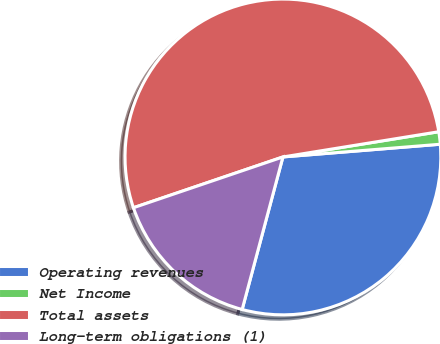<chart> <loc_0><loc_0><loc_500><loc_500><pie_chart><fcel>Operating revenues<fcel>Net Income<fcel>Total assets<fcel>Long-term obligations (1)<nl><fcel>30.44%<fcel>1.27%<fcel>52.66%<fcel>15.63%<nl></chart> 